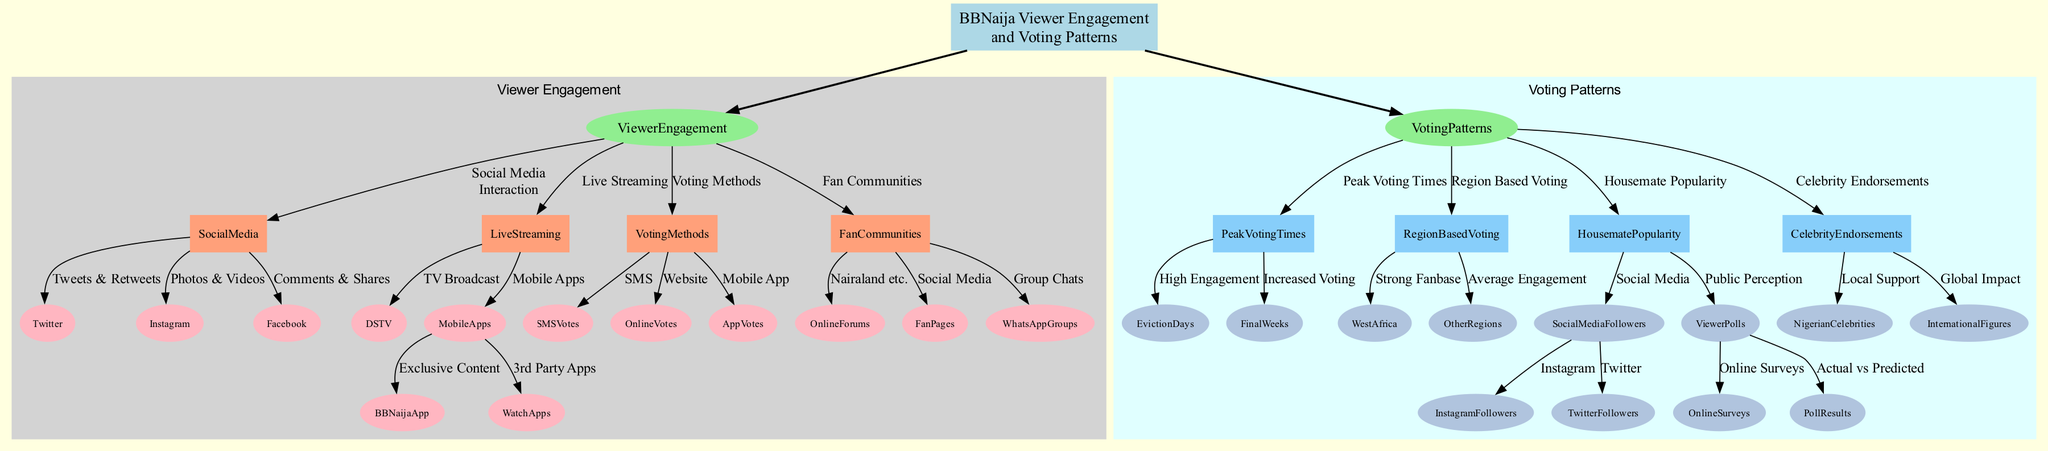What are the social media platforms mentioned in the Viewer Engagement section? The diagram highlights three social media platforms under the Social Media Interaction node: Twitter, Instagram, and Facebook. These are explicitly labeled as methods of viewer engagement.
Answer: Twitter, Instagram, Facebook How many voting methods are listed in the diagram? The Voting Methods section contains three distinct methods: SMS Votes, Online Votes, and App Votes. Each method is clearly represented with a direct edge connecting to the Voting Methods node.
Answer: 3 What is the peak voting time mentioned for BBNaija? The diagram identifies two key peak voting times: Eviction Days and Final Weeks. These are specified as significant periods of high engagement and voting activity.
Answer: Eviction Days, Final Weeks Which region shows a strong BBNaija fanbase? The diagram specifies West Africa as the region with a strong fanbase and voting activity, distinguishing it from Other Regions which are noted to have average engagement.
Answer: West Africa How do social media followers influence housemate popularity? The diagram shows that Social Media Followers, particularly on Instagram and Twitter, impact vote counts through follower count and active campaigns. This relationship is established through connections between nodes.
Answer: Social Media Followers What is indicated as a method of live streaming other than DSTV? The diagram outlines Mobile Apps as another method of live streaming. Within this category, the BBNaija App and WatchApps are specified as available options for viewers.
Answer: Mobile Apps Which type of polling influences voting patterns according to the diagram? The Viewer Polls node indicates that Online Surveys and Poll Results reflect public perception, which can influence the actual voting outcome as illustrated in the connections.
Answer: Viewer Polls What factor contributes to the influence of celebrity endorsements in voting? The diagram shows that Nigerian Celebrities and International Figures are both noted as influential in rallying support for housemates. This highlights their role in shaping viewer opinions and voting behavior.
Answer: Celebrity Endorsements What specific content does the BBNaija App provide? The BBNaija App is described in the diagram as offering exclusive content and live streams, making it a significant engagement tool for viewers. This is directly under the Mobile Apps category.
Answer: Exclusive content and live streams 